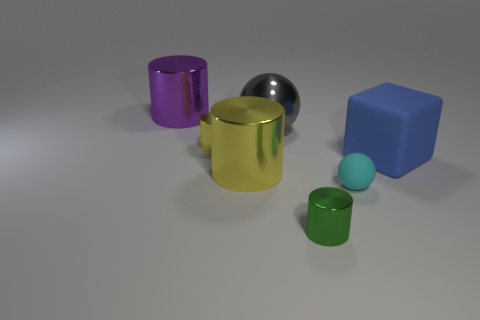Subtract 2 cylinders. How many cylinders are left? 2 Add 2 blue matte blocks. How many objects exist? 9 Subtract all gray cylinders. Subtract all blue spheres. How many cylinders are left? 4 Subtract all blocks. How many objects are left? 6 Subtract 0 purple cubes. How many objects are left? 7 Subtract all big purple metallic things. Subtract all yellow shiny things. How many objects are left? 4 Add 1 matte objects. How many matte objects are left? 3 Add 1 yellow cylinders. How many yellow cylinders exist? 3 